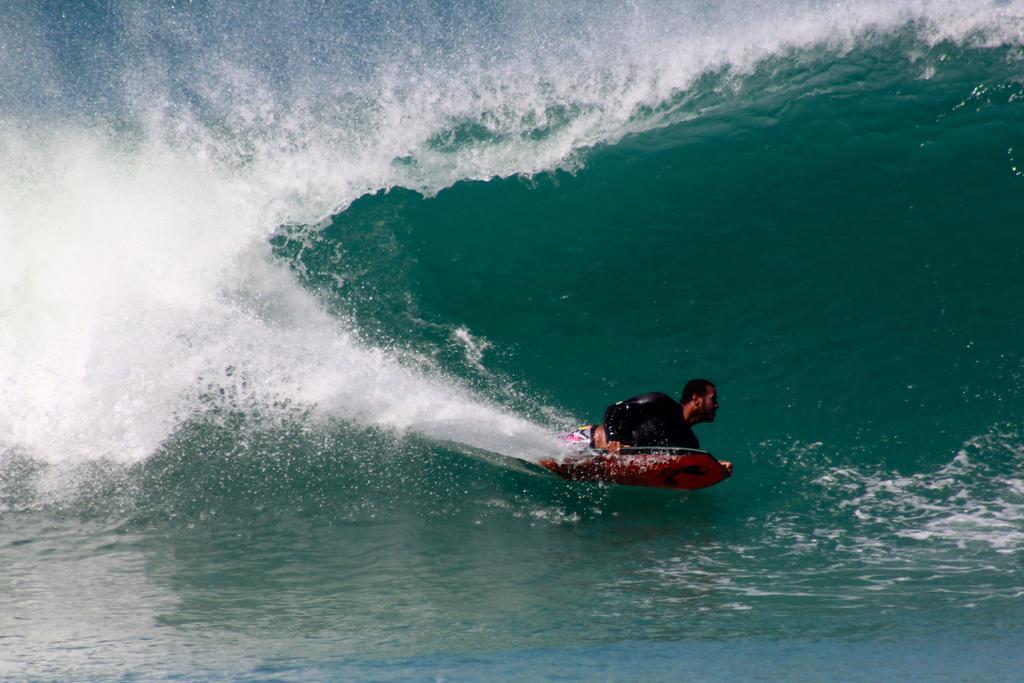In one or two sentences, can you explain what this image depicts? In the image we can see a man wearing clothes and the man is riding on the water with the help of the water board. Everywhere there is a water. 